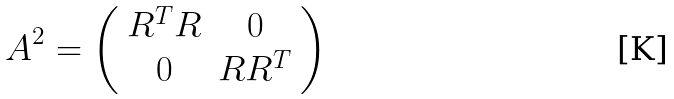<formula> <loc_0><loc_0><loc_500><loc_500>A ^ { 2 } = \left ( \begin{array} { c c } R ^ { T } R & 0 \\ 0 & R R ^ { T } \end{array} \right )</formula> 